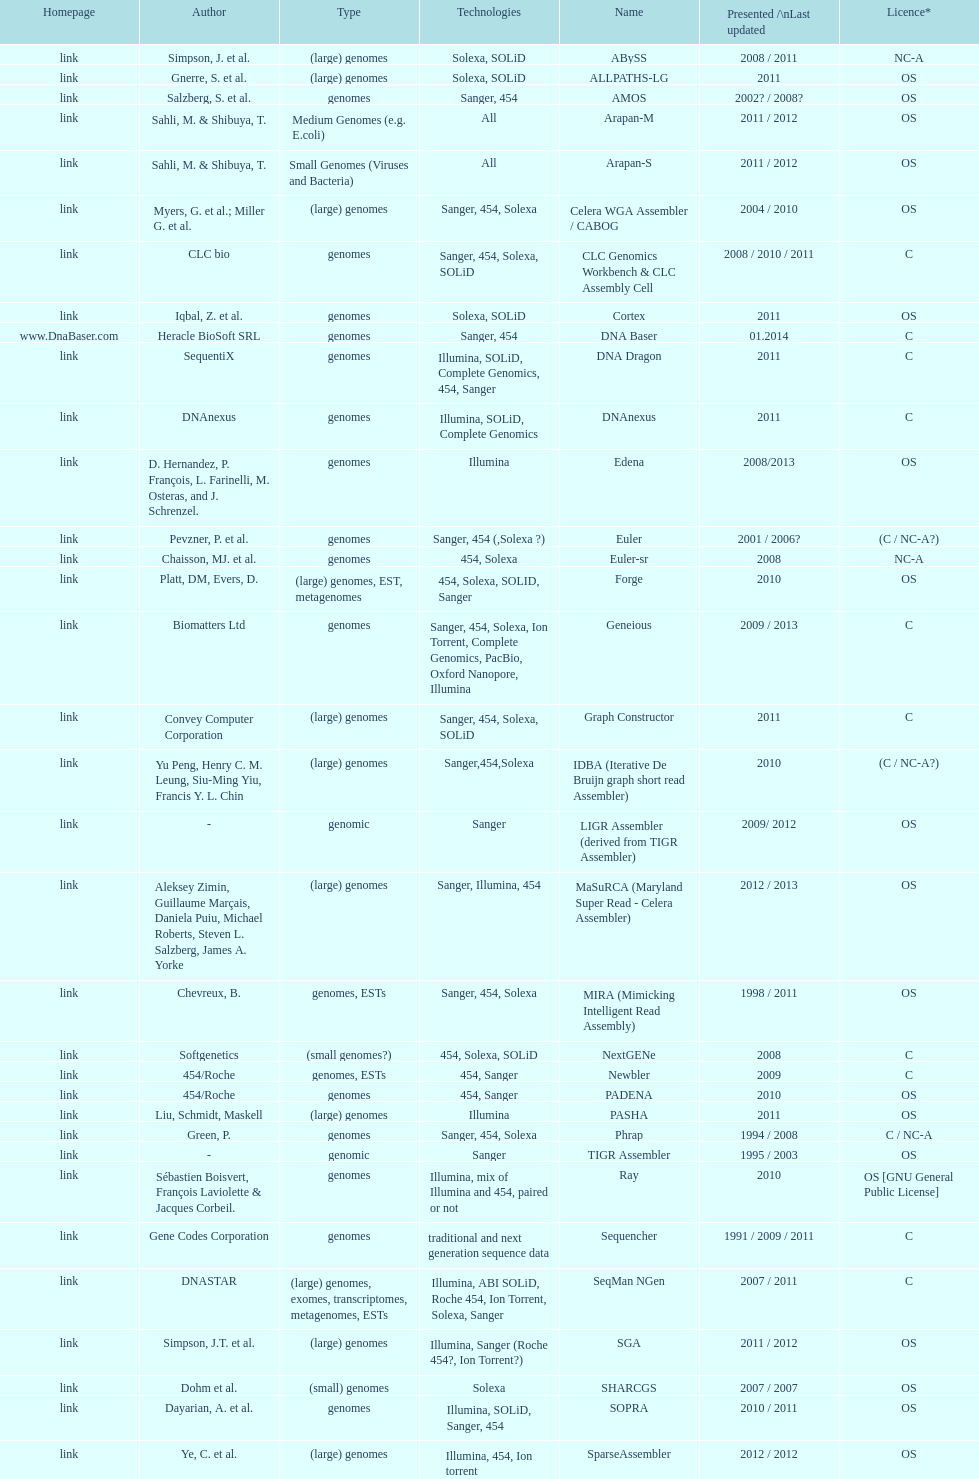What was the total number of times sahi, m. & shilbuya, t. listed as co-authors? 2. 